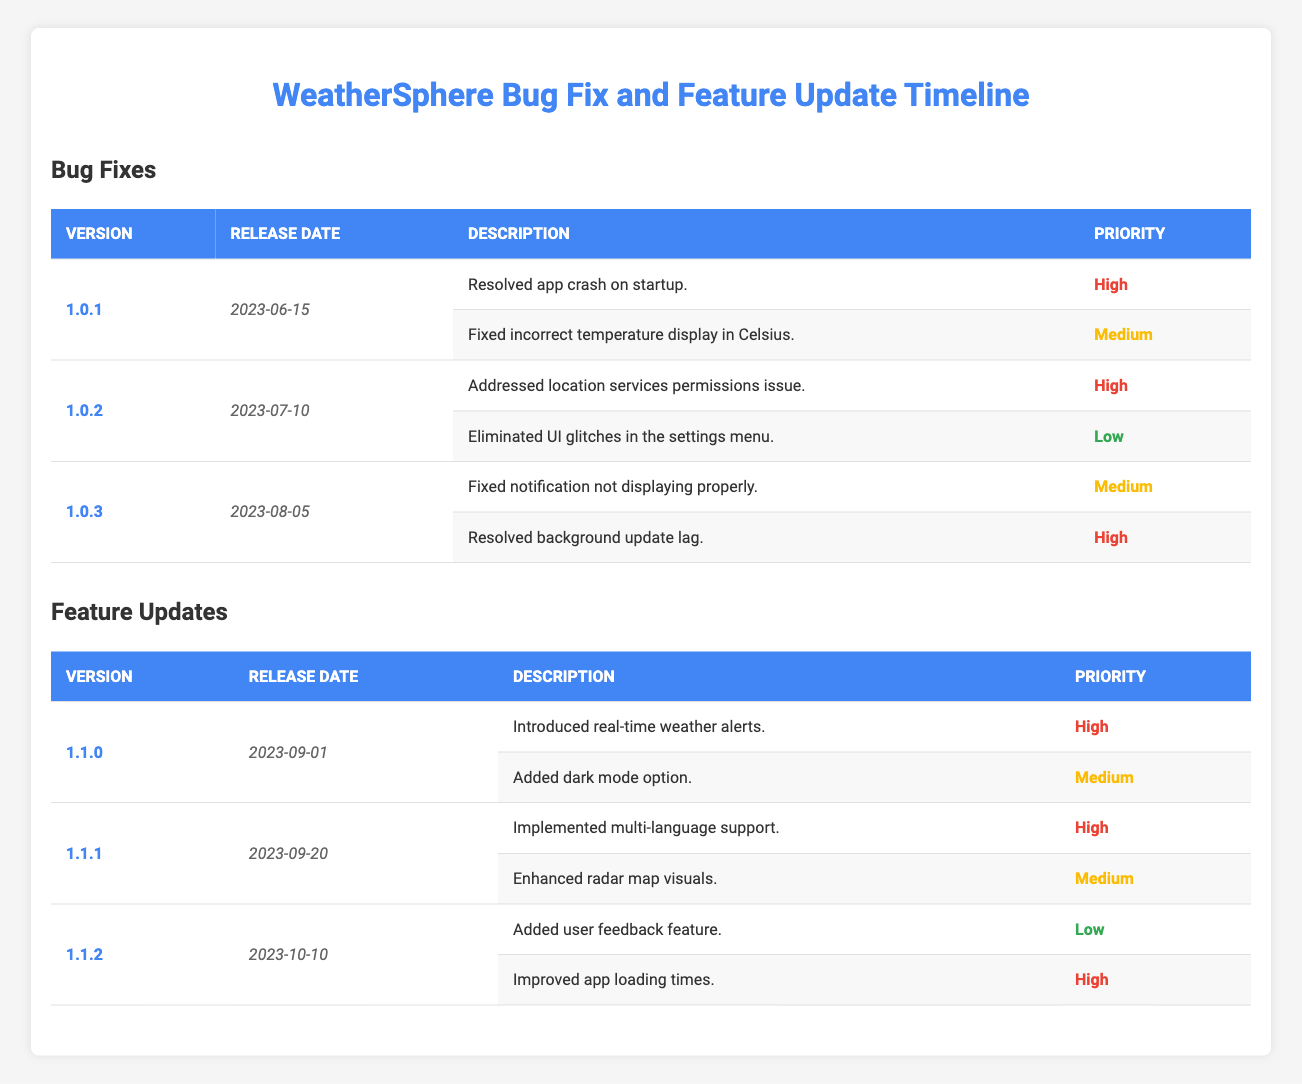What is the release date of version 1.0.2? The table shows that version 1.0.2 was released on July 10, 2023, in the Bug Fixes section.
Answer: July 10, 2023 How many bug fixes were introduced in version 1.0.3? In version 1.0.3, there are two bug fixes listed in the table.
Answer: 2 Which feature was added in version 1.1.1? The table indicates that version 1.1.1 implemented multi-language support.
Answer: Multi-language support What is the highest priority for the bug fixes in version 1.0.1? The table lists the highest priority for bug fixes in version 1.0.1 as "High" for the fix on app crash and "Medium" for incorrect temperature display.
Answer: High Did version 1.1.2 include a user feedback feature? According to the table, version 1.1.2 features the addition of a user feedback feature.
Answer: Yes How many high-priority updates are there in the feature updates section? There are four features marked as high priority across the feature updates: in versions 1.1.0 (1), 1.1.1 (1), and 1.1.2 (2), giving a total of four.
Answer: 4 Which bug fix released on August 5, 2023, had a medium priority? The bug fix in version 1.0.3 that had a medium priority is related to the notification not displaying properly.
Answer: Fixed notification not displaying properly What is the difference between the number of bug fixes and feature updates? There are three bug fix updates and three feature updates resulting in a difference of 0 (3 - 3 = 0).
Answer: 0 Which version introduced dark mode and what was its release date? The table states that the version introducing dark mode is 1.1.0, released on September 1, 2023.
Answer: 1.1.0, September 1, 2023 Are there more high-priority bug fixes or feature updates? Counting the table, there are six high-priority items (3 bug fixes and 3 feature updates), so they are equal in numbers.
Answer: Equal 